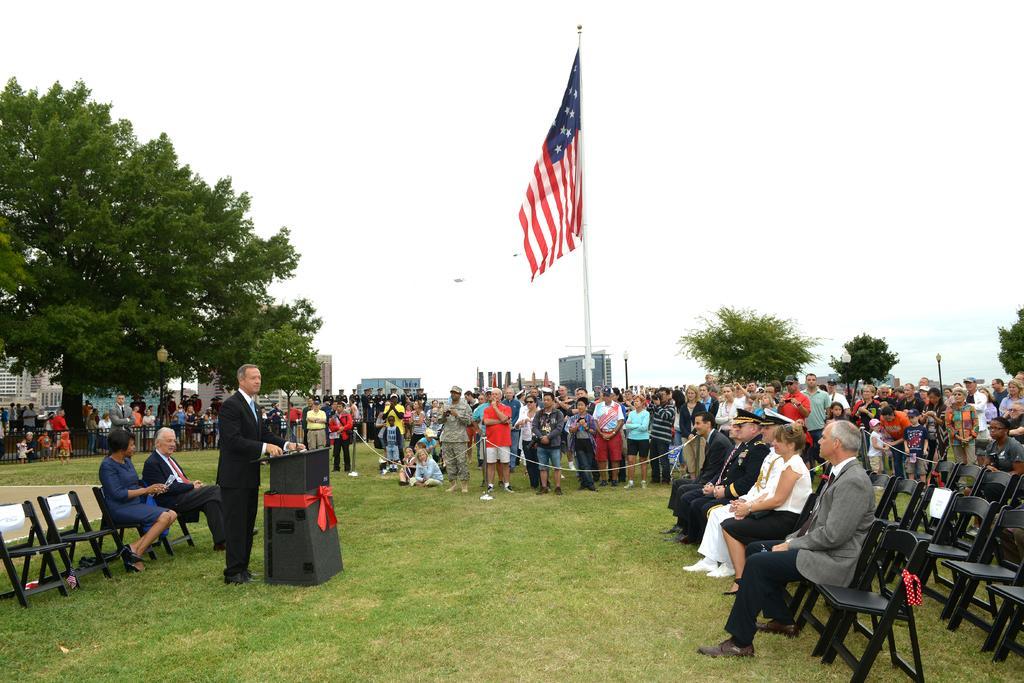Could you give a brief overview of what you see in this image? In this picture there are people, among them few people sitting and few people standing. We can see grass, podium and fence. In the background of the image we can see flag hanging to a pole, light poles, buildings, trees and sky. 